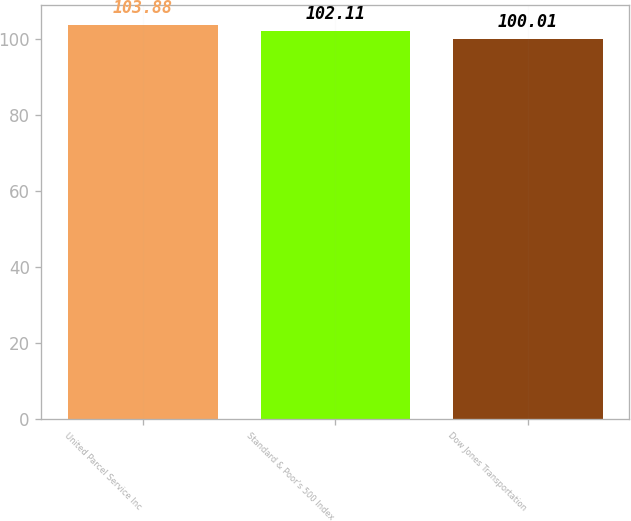<chart> <loc_0><loc_0><loc_500><loc_500><bar_chart><fcel>United Parcel Service Inc<fcel>Standard & Poor's 500 Index<fcel>Dow Jones Transportation<nl><fcel>103.88<fcel>102.11<fcel>100.01<nl></chart> 